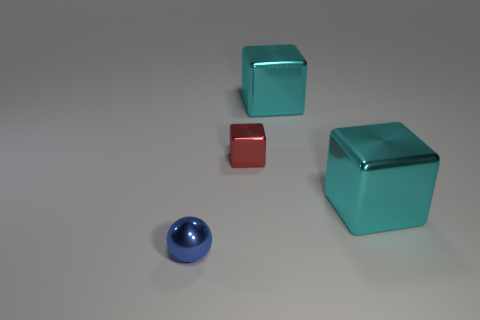Is there a tiny rubber thing of the same shape as the blue metallic object?
Offer a very short reply. No. Does the small metallic object behind the sphere have the same shape as the blue shiny thing?
Your answer should be compact. No. What number of small objects are in front of the red thing and behind the blue shiny object?
Give a very brief answer. 0. There is a metallic thing that is on the left side of the red block; what is its shape?
Keep it short and to the point. Sphere. What number of small red objects have the same material as the tiny block?
Provide a short and direct response. 0. Is the shape of the red object the same as the large metallic thing behind the red shiny cube?
Your answer should be compact. Yes. There is a big cyan block that is in front of the big block behind the small red thing; is there a small block right of it?
Provide a short and direct response. No. What is the size of the metal block that is in front of the tiny red shiny block?
Ensure brevity in your answer.  Large. What is the material of the red object that is the same size as the blue shiny sphere?
Offer a very short reply. Metal. Do the red shiny thing and the tiny blue metal thing have the same shape?
Make the answer very short. No. 